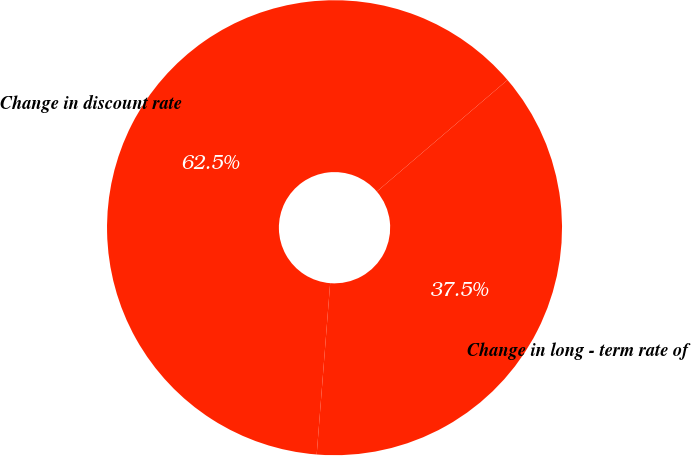Convert chart. <chart><loc_0><loc_0><loc_500><loc_500><pie_chart><fcel>Change in discount rate<fcel>Change in long - term rate of<nl><fcel>62.5%<fcel>37.5%<nl></chart> 